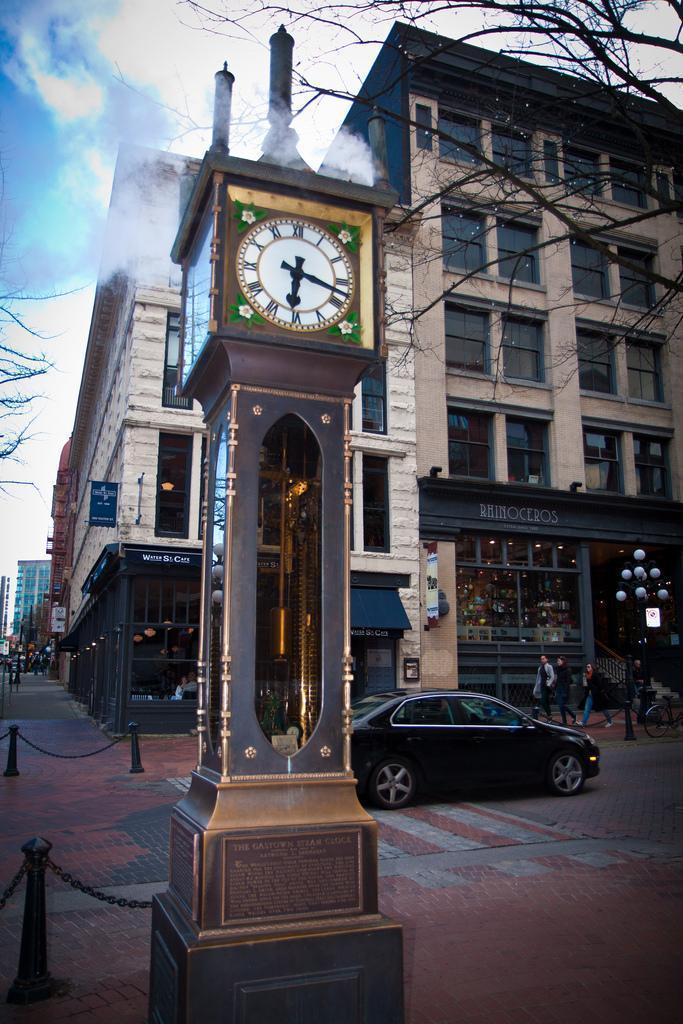How many elephants are on the street?
Give a very brief answer. 0. 